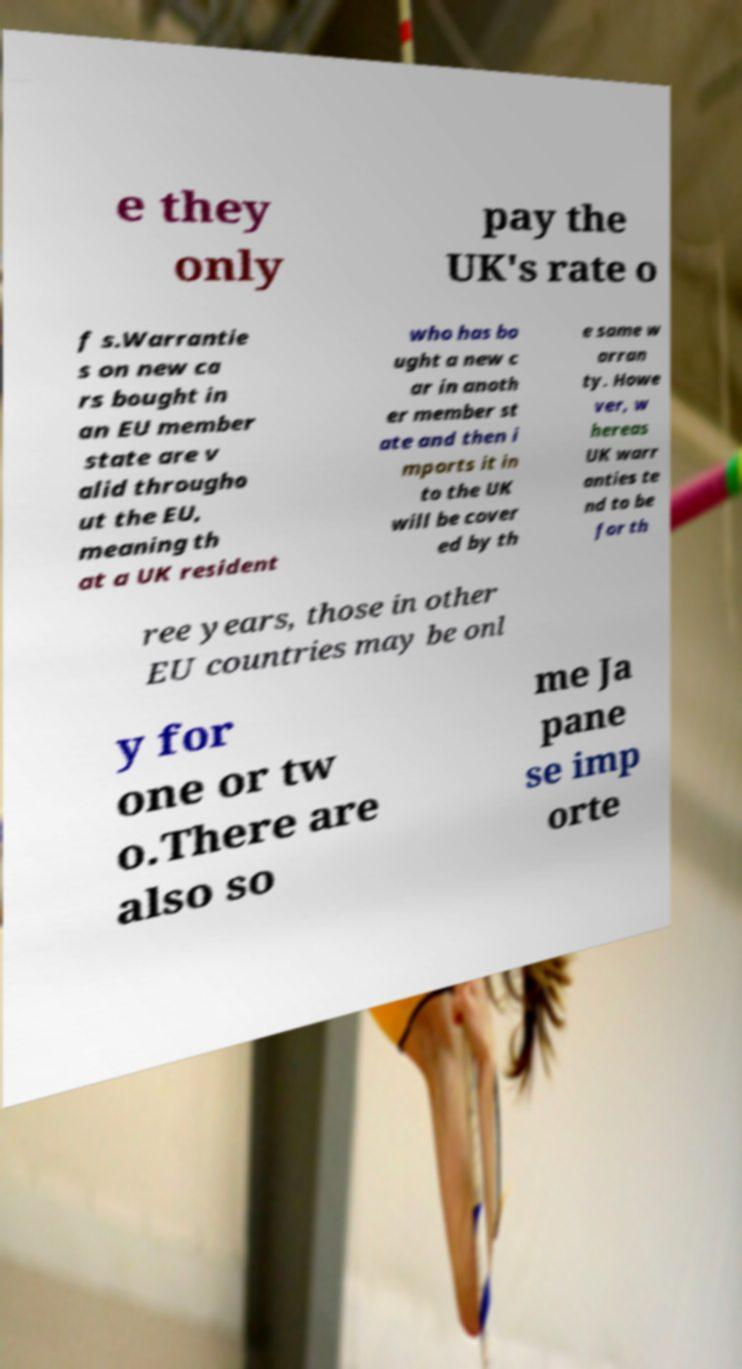There's text embedded in this image that I need extracted. Can you transcribe it verbatim? e they only pay the UK's rate o f s.Warrantie s on new ca rs bought in an EU member state are v alid througho ut the EU, meaning th at a UK resident who has bo ught a new c ar in anoth er member st ate and then i mports it in to the UK will be cover ed by th e same w arran ty. Howe ver, w hereas UK warr anties te nd to be for th ree years, those in other EU countries may be onl y for one or tw o.There are also so me Ja pane se imp orte 